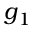<formula> <loc_0><loc_0><loc_500><loc_500>g _ { 1 }</formula> 